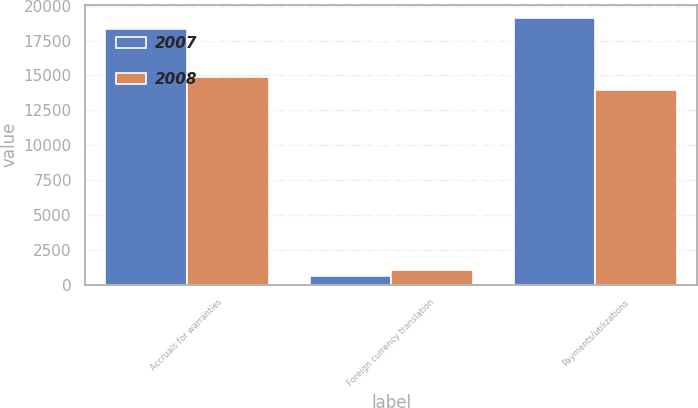<chart> <loc_0><loc_0><loc_500><loc_500><stacked_bar_chart><ecel><fcel>Accruals for warranties<fcel>Foreign currency translation<fcel>Payments/utilizations<nl><fcel>2007<fcel>18327<fcel>641<fcel>19095<nl><fcel>2008<fcel>14883<fcel>1010<fcel>13921<nl></chart> 